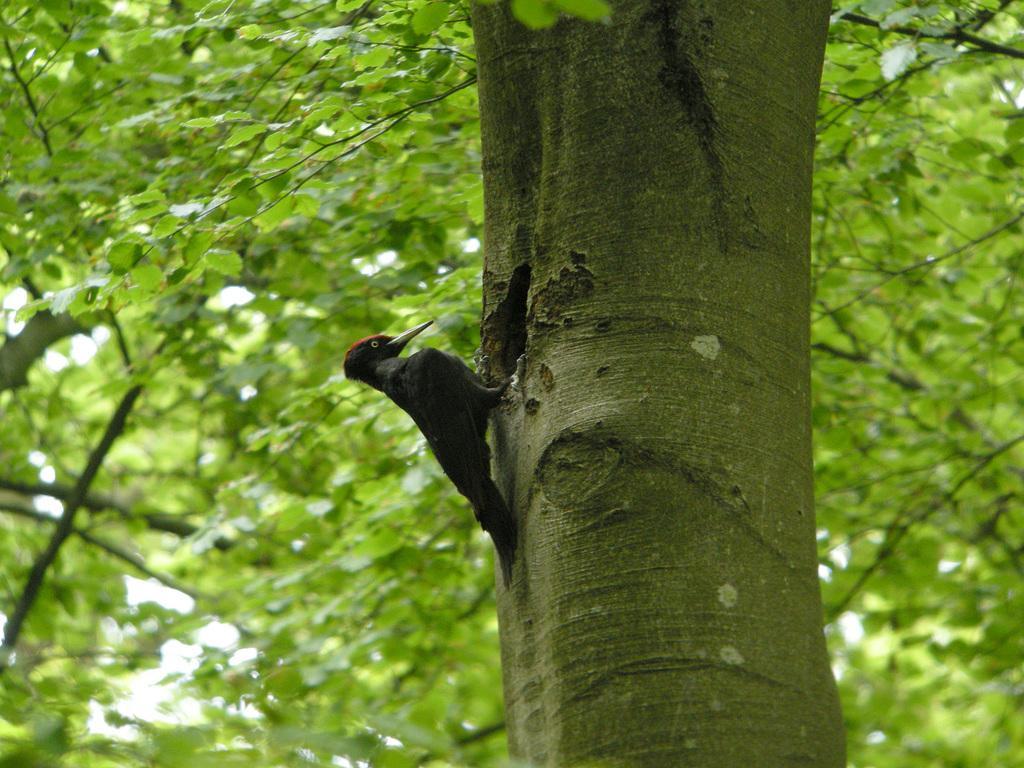Please provide a concise description of this image. In the middle of the image we can see a bird, in the background we can find few trees. 